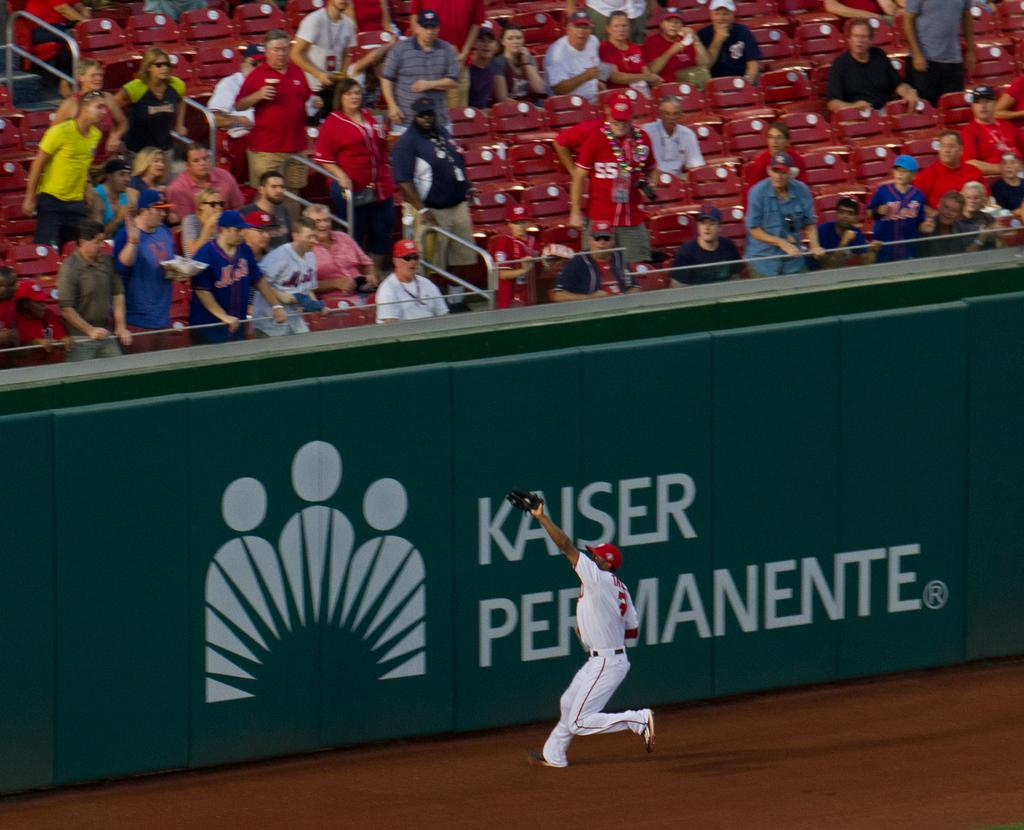Provide a one-sentence caption for the provided image. Man about to catch a ball in front of an ad that says "Kaiser Permanente". 